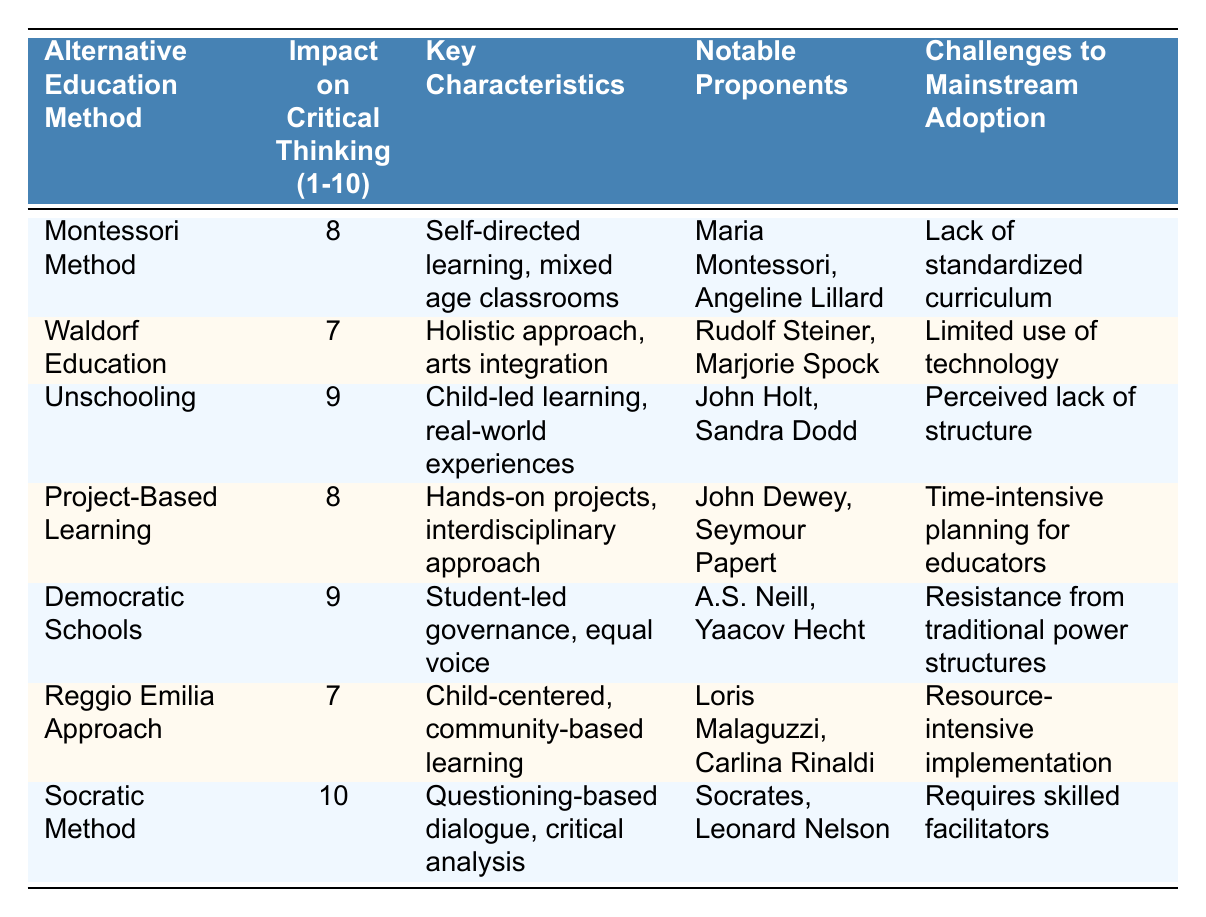What is the impact rating for the Socratic Method? The table lists the impact on critical thinking for the Socratic Method, which is stated in the second column. The value provided is 10.
Answer: 10 Which alternative education method has the highest impact on critical thinking? By scanning the table, we can see that the Socratic Method has the highest rating of 10, which is greater than all other methods listed.
Answer: Socratic Method Is the Waldorf Education method above or below an impact rating of 7? The impact rating for Waldorf Education is 7, so it is equal to 7. It is neither above nor below this value.
Answer: No How many alternative education methods have an impact rating of 9? The table shows two methods with an impact rating of 9: Unschooling and Democratic Schools. Counting these gives us a total of 2 methods.
Answer: 2 What is the average impact rating of all the education methods listed? To find the average, sum the impact ratings: 8 + 7 + 9 + 8 + 9 + 7 + 10 = 58, and divide by the number of methods (7). This gives an average of 58/7 = 8.29.
Answer: 8.29 Which method has the lowest impact rating, and what is that rating? The lowest rating in the table is 7, which is attributed to both Waldorf Education and Reggio Emilia Approach. By checking the ratings, we confirm they are both rated at 7.
Answer: Waldorf Education and Reggio Emilia Approach, rating 7 What are the key characteristics of the Democratic Schools method? The table contains a specific row for Democratic Schools, listing its key characteristics as student-led governance and equal voice. These are found in the third column under the corresponding method.
Answer: Student-led governance, equal voice Does the Montessori Method's challenges to mainstream adoption concern technology use? The listed challenge for Montessori Method in the table is the lack of a standardized curriculum, not related to technology use. Thus, the statement is false.
Answer: No Which alternative education methods focus on real-world experiences? Unschooling is the only method in the table that specifically cites real-world experiences as a key characteristic. Other methods may involve practical elements but don’t explicitly mention real-world experiences.
Answer: Unschooling 